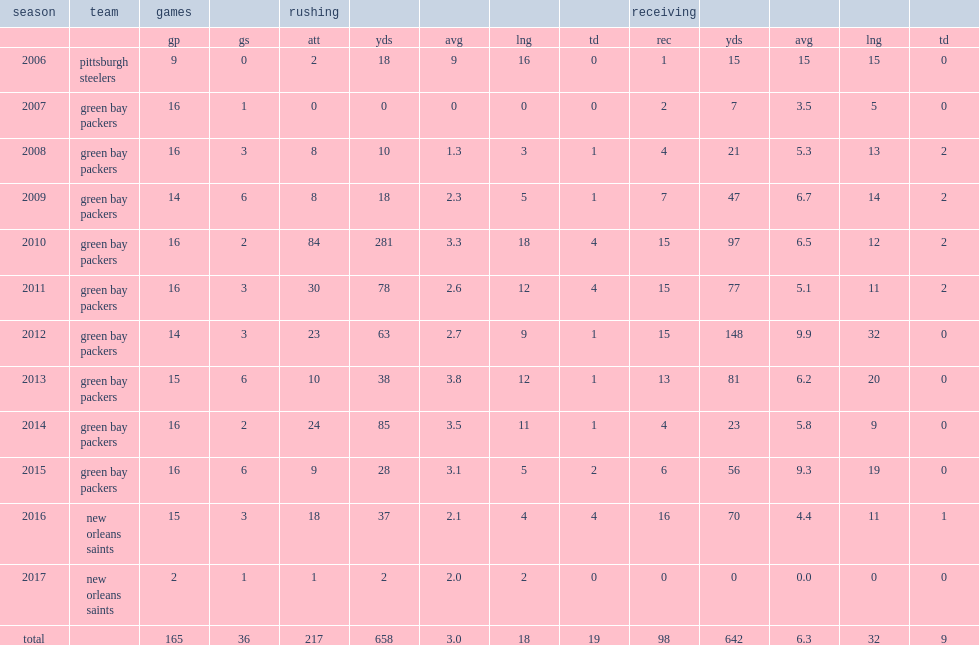How many rushing yards did kuhn get in 2010? 281.0. 